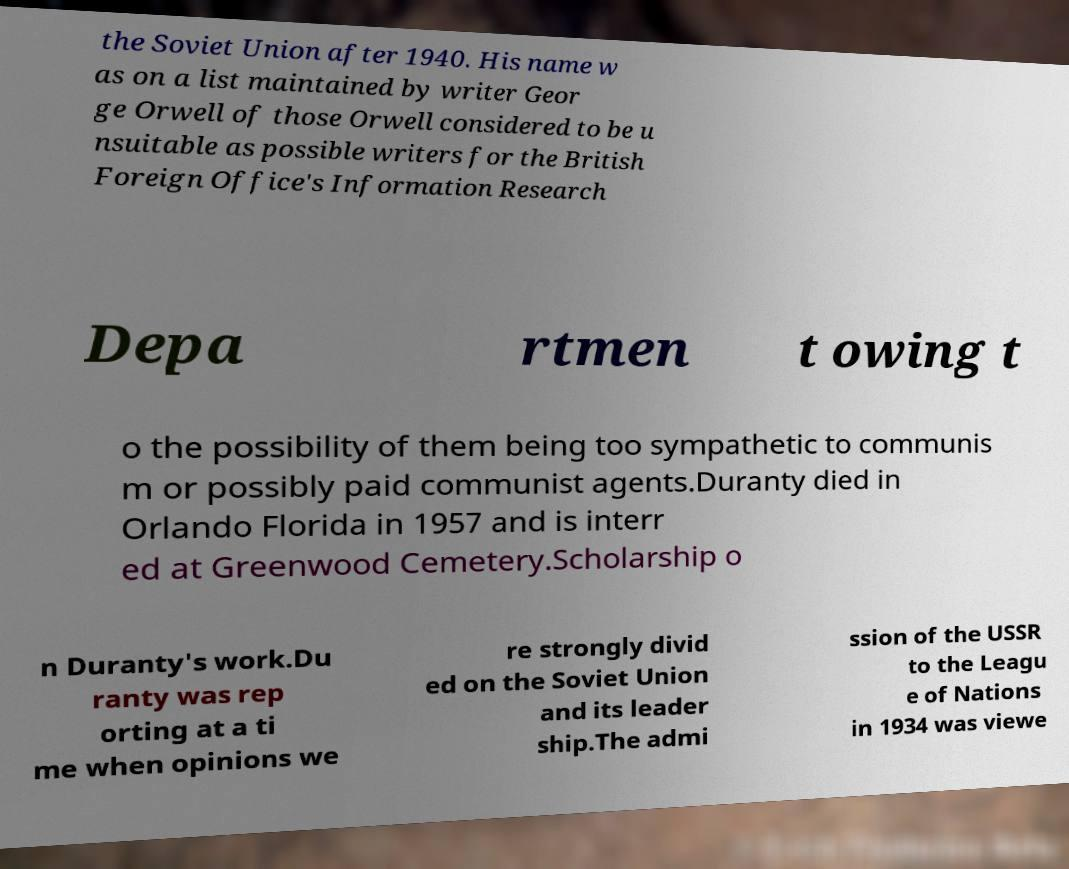There's text embedded in this image that I need extracted. Can you transcribe it verbatim? the Soviet Union after 1940. His name w as on a list maintained by writer Geor ge Orwell of those Orwell considered to be u nsuitable as possible writers for the British Foreign Office's Information Research Depa rtmen t owing t o the possibility of them being too sympathetic to communis m or possibly paid communist agents.Duranty died in Orlando Florida in 1957 and is interr ed at Greenwood Cemetery.Scholarship o n Duranty's work.Du ranty was rep orting at a ti me when opinions we re strongly divid ed on the Soviet Union and its leader ship.The admi ssion of the USSR to the Leagu e of Nations in 1934 was viewe 